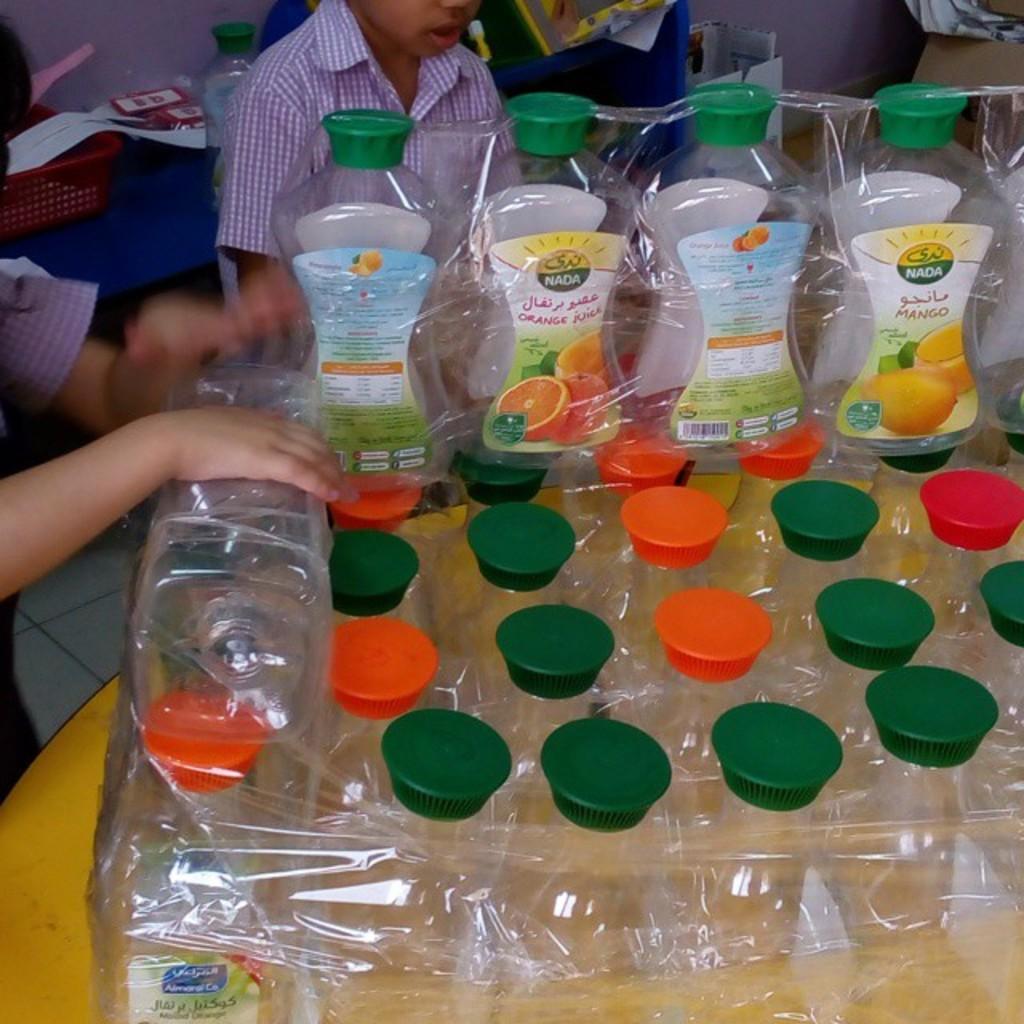Who made the juice?
Your answer should be compact. Nada. 